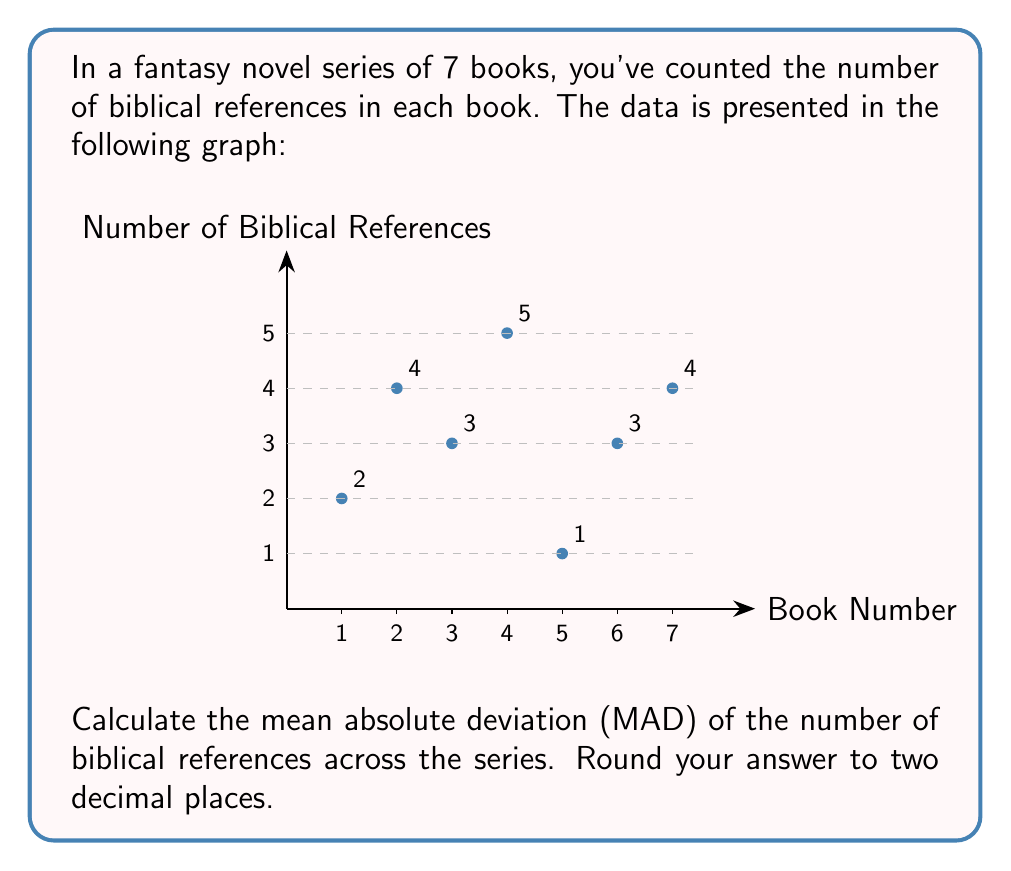Help me with this question. To calculate the mean absolute deviation (MAD), we'll follow these steps:

1) First, calculate the mean (average) number of biblical references:

   $\text{Mean} = \frac{2 + 4 + 3 + 5 + 1 + 3 + 4}{7} = \frac{22}{7} \approx 3.14$

2) Now, calculate the absolute deviation of each data point from the mean:

   Book 1: $|2 - 3.14| = 1.14$
   Book 2: $|4 - 3.14| = 0.86$
   Book 3: $|3 - 3.14| = 0.14$
   Book 4: $|5 - 3.14| = 1.86$
   Book 5: $|1 - 3.14| = 2.14$
   Book 6: $|3 - 3.14| = 0.14$
   Book 7: $|4 - 3.14| = 0.86$

3) Calculate the mean of these absolute deviations:

   $\text{MAD} = \frac{1.14 + 0.86 + 0.14 + 1.86 + 2.14 + 0.14 + 0.86}{7}$

4) Simplify:

   $\text{MAD} = \frac{7.14}{7} = 1.02$

5) Round to two decimal places:

   $\text{MAD} \approx 1.02$

Therefore, the mean absolute deviation of biblical references in the fantasy series is approximately 1.02.
Answer: 1.02 